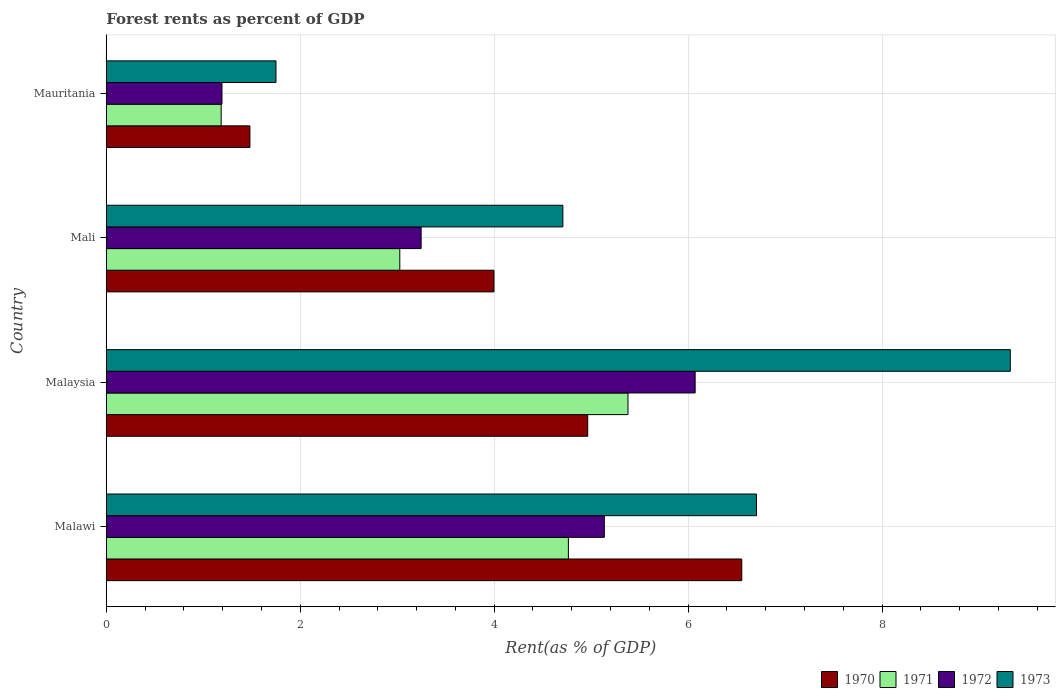How many groups of bars are there?
Your answer should be very brief. 4. Are the number of bars per tick equal to the number of legend labels?
Give a very brief answer. Yes. How many bars are there on the 2nd tick from the top?
Ensure brevity in your answer.  4. How many bars are there on the 3rd tick from the bottom?
Offer a terse response. 4. What is the label of the 4th group of bars from the top?
Provide a short and direct response. Malawi. What is the forest rent in 1972 in Mauritania?
Offer a terse response. 1.19. Across all countries, what is the maximum forest rent in 1971?
Your answer should be compact. 5.38. Across all countries, what is the minimum forest rent in 1972?
Keep it short and to the point. 1.19. In which country was the forest rent in 1972 maximum?
Your response must be concise. Malaysia. In which country was the forest rent in 1973 minimum?
Offer a terse response. Mauritania. What is the total forest rent in 1973 in the graph?
Ensure brevity in your answer.  22.49. What is the difference between the forest rent in 1971 in Malaysia and that in Mali?
Provide a succinct answer. 2.35. What is the difference between the forest rent in 1970 in Malaysia and the forest rent in 1971 in Mauritania?
Keep it short and to the point. 3.78. What is the average forest rent in 1971 per country?
Offer a terse response. 3.59. What is the difference between the forest rent in 1973 and forest rent in 1970 in Mauritania?
Offer a terse response. 0.27. In how many countries, is the forest rent in 1972 greater than 7.2 %?
Give a very brief answer. 0. What is the ratio of the forest rent in 1971 in Malaysia to that in Mali?
Keep it short and to the point. 1.78. Is the forest rent in 1971 in Malaysia less than that in Mali?
Your response must be concise. No. Is the difference between the forest rent in 1973 in Malaysia and Mali greater than the difference between the forest rent in 1970 in Malaysia and Mali?
Provide a short and direct response. Yes. What is the difference between the highest and the second highest forest rent in 1973?
Your answer should be very brief. 2.62. What is the difference between the highest and the lowest forest rent in 1971?
Ensure brevity in your answer.  4.19. In how many countries, is the forest rent in 1972 greater than the average forest rent in 1972 taken over all countries?
Your answer should be compact. 2. Is it the case that in every country, the sum of the forest rent in 1973 and forest rent in 1972 is greater than the sum of forest rent in 1970 and forest rent in 1971?
Your answer should be compact. No. What does the 3rd bar from the top in Mali represents?
Your answer should be very brief. 1971. Is it the case that in every country, the sum of the forest rent in 1972 and forest rent in 1973 is greater than the forest rent in 1971?
Keep it short and to the point. Yes. Are all the bars in the graph horizontal?
Provide a succinct answer. Yes. What is the difference between two consecutive major ticks on the X-axis?
Give a very brief answer. 2. Does the graph contain any zero values?
Provide a short and direct response. No. Does the graph contain grids?
Your response must be concise. Yes. Where does the legend appear in the graph?
Your response must be concise. Bottom right. What is the title of the graph?
Give a very brief answer. Forest rents as percent of GDP. What is the label or title of the X-axis?
Make the answer very short. Rent(as % of GDP). What is the Rent(as % of GDP) of 1970 in Malawi?
Keep it short and to the point. 6.55. What is the Rent(as % of GDP) in 1971 in Malawi?
Offer a terse response. 4.77. What is the Rent(as % of GDP) of 1972 in Malawi?
Provide a succinct answer. 5.14. What is the Rent(as % of GDP) of 1973 in Malawi?
Make the answer very short. 6.71. What is the Rent(as % of GDP) in 1970 in Malaysia?
Offer a very short reply. 4.96. What is the Rent(as % of GDP) in 1971 in Malaysia?
Keep it short and to the point. 5.38. What is the Rent(as % of GDP) of 1972 in Malaysia?
Give a very brief answer. 6.07. What is the Rent(as % of GDP) of 1973 in Malaysia?
Offer a very short reply. 9.32. What is the Rent(as % of GDP) in 1970 in Mali?
Give a very brief answer. 4. What is the Rent(as % of GDP) of 1971 in Mali?
Make the answer very short. 3.03. What is the Rent(as % of GDP) in 1972 in Mali?
Offer a very short reply. 3.25. What is the Rent(as % of GDP) in 1973 in Mali?
Your response must be concise. 4.71. What is the Rent(as % of GDP) of 1970 in Mauritania?
Your answer should be very brief. 1.48. What is the Rent(as % of GDP) in 1971 in Mauritania?
Offer a terse response. 1.19. What is the Rent(as % of GDP) in 1972 in Mauritania?
Your response must be concise. 1.19. What is the Rent(as % of GDP) in 1973 in Mauritania?
Your response must be concise. 1.75. Across all countries, what is the maximum Rent(as % of GDP) of 1970?
Make the answer very short. 6.55. Across all countries, what is the maximum Rent(as % of GDP) of 1971?
Offer a very short reply. 5.38. Across all countries, what is the maximum Rent(as % of GDP) in 1972?
Provide a short and direct response. 6.07. Across all countries, what is the maximum Rent(as % of GDP) of 1973?
Give a very brief answer. 9.32. Across all countries, what is the minimum Rent(as % of GDP) in 1970?
Provide a short and direct response. 1.48. Across all countries, what is the minimum Rent(as % of GDP) of 1971?
Your response must be concise. 1.19. Across all countries, what is the minimum Rent(as % of GDP) in 1972?
Your response must be concise. 1.19. Across all countries, what is the minimum Rent(as % of GDP) in 1973?
Ensure brevity in your answer.  1.75. What is the total Rent(as % of GDP) in 1970 in the graph?
Provide a short and direct response. 17. What is the total Rent(as % of GDP) of 1971 in the graph?
Your response must be concise. 14.36. What is the total Rent(as % of GDP) in 1972 in the graph?
Give a very brief answer. 15.65. What is the total Rent(as % of GDP) of 1973 in the graph?
Give a very brief answer. 22.49. What is the difference between the Rent(as % of GDP) of 1970 in Malawi and that in Malaysia?
Make the answer very short. 1.59. What is the difference between the Rent(as % of GDP) in 1971 in Malawi and that in Malaysia?
Give a very brief answer. -0.61. What is the difference between the Rent(as % of GDP) in 1972 in Malawi and that in Malaysia?
Your answer should be compact. -0.94. What is the difference between the Rent(as % of GDP) in 1973 in Malawi and that in Malaysia?
Keep it short and to the point. -2.62. What is the difference between the Rent(as % of GDP) of 1970 in Malawi and that in Mali?
Your answer should be very brief. 2.55. What is the difference between the Rent(as % of GDP) in 1971 in Malawi and that in Mali?
Make the answer very short. 1.74. What is the difference between the Rent(as % of GDP) of 1972 in Malawi and that in Mali?
Your answer should be very brief. 1.89. What is the difference between the Rent(as % of GDP) in 1973 in Malawi and that in Mali?
Give a very brief answer. 2. What is the difference between the Rent(as % of GDP) of 1970 in Malawi and that in Mauritania?
Make the answer very short. 5.07. What is the difference between the Rent(as % of GDP) in 1971 in Malawi and that in Mauritania?
Your answer should be compact. 3.58. What is the difference between the Rent(as % of GDP) in 1972 in Malawi and that in Mauritania?
Offer a terse response. 3.94. What is the difference between the Rent(as % of GDP) of 1973 in Malawi and that in Mauritania?
Provide a short and direct response. 4.96. What is the difference between the Rent(as % of GDP) of 1970 in Malaysia and that in Mali?
Offer a very short reply. 0.97. What is the difference between the Rent(as % of GDP) in 1971 in Malaysia and that in Mali?
Give a very brief answer. 2.35. What is the difference between the Rent(as % of GDP) of 1972 in Malaysia and that in Mali?
Ensure brevity in your answer.  2.83. What is the difference between the Rent(as % of GDP) of 1973 in Malaysia and that in Mali?
Your response must be concise. 4.61. What is the difference between the Rent(as % of GDP) of 1970 in Malaysia and that in Mauritania?
Your answer should be compact. 3.48. What is the difference between the Rent(as % of GDP) of 1971 in Malaysia and that in Mauritania?
Give a very brief answer. 4.19. What is the difference between the Rent(as % of GDP) of 1972 in Malaysia and that in Mauritania?
Your answer should be compact. 4.88. What is the difference between the Rent(as % of GDP) of 1973 in Malaysia and that in Mauritania?
Your response must be concise. 7.57. What is the difference between the Rent(as % of GDP) in 1970 in Mali and that in Mauritania?
Give a very brief answer. 2.52. What is the difference between the Rent(as % of GDP) in 1971 in Mali and that in Mauritania?
Offer a terse response. 1.84. What is the difference between the Rent(as % of GDP) in 1972 in Mali and that in Mauritania?
Your response must be concise. 2.05. What is the difference between the Rent(as % of GDP) of 1973 in Mali and that in Mauritania?
Your answer should be compact. 2.96. What is the difference between the Rent(as % of GDP) of 1970 in Malawi and the Rent(as % of GDP) of 1971 in Malaysia?
Offer a very short reply. 1.17. What is the difference between the Rent(as % of GDP) of 1970 in Malawi and the Rent(as % of GDP) of 1972 in Malaysia?
Provide a short and direct response. 0.48. What is the difference between the Rent(as % of GDP) of 1970 in Malawi and the Rent(as % of GDP) of 1973 in Malaysia?
Your answer should be compact. -2.77. What is the difference between the Rent(as % of GDP) in 1971 in Malawi and the Rent(as % of GDP) in 1972 in Malaysia?
Your answer should be very brief. -1.31. What is the difference between the Rent(as % of GDP) of 1971 in Malawi and the Rent(as % of GDP) of 1973 in Malaysia?
Your response must be concise. -4.56. What is the difference between the Rent(as % of GDP) in 1972 in Malawi and the Rent(as % of GDP) in 1973 in Malaysia?
Ensure brevity in your answer.  -4.19. What is the difference between the Rent(as % of GDP) of 1970 in Malawi and the Rent(as % of GDP) of 1971 in Mali?
Your response must be concise. 3.53. What is the difference between the Rent(as % of GDP) of 1970 in Malawi and the Rent(as % of GDP) of 1972 in Mali?
Your answer should be very brief. 3.31. What is the difference between the Rent(as % of GDP) in 1970 in Malawi and the Rent(as % of GDP) in 1973 in Mali?
Offer a very short reply. 1.84. What is the difference between the Rent(as % of GDP) of 1971 in Malawi and the Rent(as % of GDP) of 1972 in Mali?
Give a very brief answer. 1.52. What is the difference between the Rent(as % of GDP) in 1971 in Malawi and the Rent(as % of GDP) in 1973 in Mali?
Give a very brief answer. 0.06. What is the difference between the Rent(as % of GDP) in 1972 in Malawi and the Rent(as % of GDP) in 1973 in Mali?
Give a very brief answer. 0.43. What is the difference between the Rent(as % of GDP) in 1970 in Malawi and the Rent(as % of GDP) in 1971 in Mauritania?
Ensure brevity in your answer.  5.37. What is the difference between the Rent(as % of GDP) in 1970 in Malawi and the Rent(as % of GDP) in 1972 in Mauritania?
Ensure brevity in your answer.  5.36. What is the difference between the Rent(as % of GDP) in 1970 in Malawi and the Rent(as % of GDP) in 1973 in Mauritania?
Offer a terse response. 4.8. What is the difference between the Rent(as % of GDP) in 1971 in Malawi and the Rent(as % of GDP) in 1972 in Mauritania?
Keep it short and to the point. 3.57. What is the difference between the Rent(as % of GDP) of 1971 in Malawi and the Rent(as % of GDP) of 1973 in Mauritania?
Your answer should be compact. 3.02. What is the difference between the Rent(as % of GDP) in 1972 in Malawi and the Rent(as % of GDP) in 1973 in Mauritania?
Keep it short and to the point. 3.39. What is the difference between the Rent(as % of GDP) in 1970 in Malaysia and the Rent(as % of GDP) in 1971 in Mali?
Your answer should be compact. 1.94. What is the difference between the Rent(as % of GDP) in 1970 in Malaysia and the Rent(as % of GDP) in 1972 in Mali?
Provide a short and direct response. 1.72. What is the difference between the Rent(as % of GDP) in 1970 in Malaysia and the Rent(as % of GDP) in 1973 in Mali?
Provide a succinct answer. 0.26. What is the difference between the Rent(as % of GDP) of 1971 in Malaysia and the Rent(as % of GDP) of 1972 in Mali?
Provide a succinct answer. 2.13. What is the difference between the Rent(as % of GDP) of 1971 in Malaysia and the Rent(as % of GDP) of 1973 in Mali?
Make the answer very short. 0.67. What is the difference between the Rent(as % of GDP) of 1972 in Malaysia and the Rent(as % of GDP) of 1973 in Mali?
Make the answer very short. 1.36. What is the difference between the Rent(as % of GDP) of 1970 in Malaysia and the Rent(as % of GDP) of 1971 in Mauritania?
Offer a very short reply. 3.78. What is the difference between the Rent(as % of GDP) in 1970 in Malaysia and the Rent(as % of GDP) in 1972 in Mauritania?
Offer a terse response. 3.77. What is the difference between the Rent(as % of GDP) of 1970 in Malaysia and the Rent(as % of GDP) of 1973 in Mauritania?
Keep it short and to the point. 3.21. What is the difference between the Rent(as % of GDP) of 1971 in Malaysia and the Rent(as % of GDP) of 1972 in Mauritania?
Give a very brief answer. 4.19. What is the difference between the Rent(as % of GDP) in 1971 in Malaysia and the Rent(as % of GDP) in 1973 in Mauritania?
Keep it short and to the point. 3.63. What is the difference between the Rent(as % of GDP) of 1972 in Malaysia and the Rent(as % of GDP) of 1973 in Mauritania?
Make the answer very short. 4.32. What is the difference between the Rent(as % of GDP) of 1970 in Mali and the Rent(as % of GDP) of 1971 in Mauritania?
Make the answer very short. 2.81. What is the difference between the Rent(as % of GDP) in 1970 in Mali and the Rent(as % of GDP) in 1972 in Mauritania?
Provide a succinct answer. 2.8. What is the difference between the Rent(as % of GDP) in 1970 in Mali and the Rent(as % of GDP) in 1973 in Mauritania?
Give a very brief answer. 2.25. What is the difference between the Rent(as % of GDP) in 1971 in Mali and the Rent(as % of GDP) in 1972 in Mauritania?
Provide a short and direct response. 1.83. What is the difference between the Rent(as % of GDP) of 1971 in Mali and the Rent(as % of GDP) of 1973 in Mauritania?
Make the answer very short. 1.28. What is the difference between the Rent(as % of GDP) of 1972 in Mali and the Rent(as % of GDP) of 1973 in Mauritania?
Give a very brief answer. 1.5. What is the average Rent(as % of GDP) of 1970 per country?
Give a very brief answer. 4.25. What is the average Rent(as % of GDP) in 1971 per country?
Give a very brief answer. 3.59. What is the average Rent(as % of GDP) in 1972 per country?
Provide a short and direct response. 3.91. What is the average Rent(as % of GDP) in 1973 per country?
Provide a succinct answer. 5.62. What is the difference between the Rent(as % of GDP) in 1970 and Rent(as % of GDP) in 1971 in Malawi?
Offer a very short reply. 1.79. What is the difference between the Rent(as % of GDP) in 1970 and Rent(as % of GDP) in 1972 in Malawi?
Your response must be concise. 1.42. What is the difference between the Rent(as % of GDP) of 1970 and Rent(as % of GDP) of 1973 in Malawi?
Your answer should be very brief. -0.15. What is the difference between the Rent(as % of GDP) in 1971 and Rent(as % of GDP) in 1972 in Malawi?
Provide a short and direct response. -0.37. What is the difference between the Rent(as % of GDP) of 1971 and Rent(as % of GDP) of 1973 in Malawi?
Your answer should be very brief. -1.94. What is the difference between the Rent(as % of GDP) in 1972 and Rent(as % of GDP) in 1973 in Malawi?
Provide a short and direct response. -1.57. What is the difference between the Rent(as % of GDP) of 1970 and Rent(as % of GDP) of 1971 in Malaysia?
Ensure brevity in your answer.  -0.42. What is the difference between the Rent(as % of GDP) in 1970 and Rent(as % of GDP) in 1972 in Malaysia?
Ensure brevity in your answer.  -1.11. What is the difference between the Rent(as % of GDP) of 1970 and Rent(as % of GDP) of 1973 in Malaysia?
Your answer should be very brief. -4.36. What is the difference between the Rent(as % of GDP) of 1971 and Rent(as % of GDP) of 1972 in Malaysia?
Keep it short and to the point. -0.69. What is the difference between the Rent(as % of GDP) of 1971 and Rent(as % of GDP) of 1973 in Malaysia?
Your answer should be compact. -3.94. What is the difference between the Rent(as % of GDP) of 1972 and Rent(as % of GDP) of 1973 in Malaysia?
Make the answer very short. -3.25. What is the difference between the Rent(as % of GDP) in 1970 and Rent(as % of GDP) in 1971 in Mali?
Give a very brief answer. 0.97. What is the difference between the Rent(as % of GDP) in 1970 and Rent(as % of GDP) in 1972 in Mali?
Ensure brevity in your answer.  0.75. What is the difference between the Rent(as % of GDP) of 1970 and Rent(as % of GDP) of 1973 in Mali?
Your response must be concise. -0.71. What is the difference between the Rent(as % of GDP) in 1971 and Rent(as % of GDP) in 1972 in Mali?
Provide a succinct answer. -0.22. What is the difference between the Rent(as % of GDP) in 1971 and Rent(as % of GDP) in 1973 in Mali?
Give a very brief answer. -1.68. What is the difference between the Rent(as % of GDP) in 1972 and Rent(as % of GDP) in 1973 in Mali?
Keep it short and to the point. -1.46. What is the difference between the Rent(as % of GDP) of 1970 and Rent(as % of GDP) of 1971 in Mauritania?
Offer a terse response. 0.3. What is the difference between the Rent(as % of GDP) in 1970 and Rent(as % of GDP) in 1972 in Mauritania?
Offer a very short reply. 0.29. What is the difference between the Rent(as % of GDP) of 1970 and Rent(as % of GDP) of 1973 in Mauritania?
Your response must be concise. -0.27. What is the difference between the Rent(as % of GDP) of 1971 and Rent(as % of GDP) of 1972 in Mauritania?
Provide a short and direct response. -0.01. What is the difference between the Rent(as % of GDP) of 1971 and Rent(as % of GDP) of 1973 in Mauritania?
Offer a terse response. -0.57. What is the difference between the Rent(as % of GDP) in 1972 and Rent(as % of GDP) in 1973 in Mauritania?
Ensure brevity in your answer.  -0.56. What is the ratio of the Rent(as % of GDP) in 1970 in Malawi to that in Malaysia?
Offer a very short reply. 1.32. What is the ratio of the Rent(as % of GDP) of 1971 in Malawi to that in Malaysia?
Your answer should be very brief. 0.89. What is the ratio of the Rent(as % of GDP) in 1972 in Malawi to that in Malaysia?
Keep it short and to the point. 0.85. What is the ratio of the Rent(as % of GDP) in 1973 in Malawi to that in Malaysia?
Your answer should be very brief. 0.72. What is the ratio of the Rent(as % of GDP) of 1970 in Malawi to that in Mali?
Your answer should be very brief. 1.64. What is the ratio of the Rent(as % of GDP) in 1971 in Malawi to that in Mali?
Offer a very short reply. 1.57. What is the ratio of the Rent(as % of GDP) in 1972 in Malawi to that in Mali?
Provide a short and direct response. 1.58. What is the ratio of the Rent(as % of GDP) of 1973 in Malawi to that in Mali?
Keep it short and to the point. 1.42. What is the ratio of the Rent(as % of GDP) of 1970 in Malawi to that in Mauritania?
Offer a very short reply. 4.42. What is the ratio of the Rent(as % of GDP) of 1971 in Malawi to that in Mauritania?
Your response must be concise. 4.02. What is the ratio of the Rent(as % of GDP) in 1972 in Malawi to that in Mauritania?
Keep it short and to the point. 4.3. What is the ratio of the Rent(as % of GDP) of 1973 in Malawi to that in Mauritania?
Your response must be concise. 3.83. What is the ratio of the Rent(as % of GDP) in 1970 in Malaysia to that in Mali?
Your response must be concise. 1.24. What is the ratio of the Rent(as % of GDP) of 1971 in Malaysia to that in Mali?
Your response must be concise. 1.78. What is the ratio of the Rent(as % of GDP) in 1972 in Malaysia to that in Mali?
Offer a very short reply. 1.87. What is the ratio of the Rent(as % of GDP) in 1973 in Malaysia to that in Mali?
Keep it short and to the point. 1.98. What is the ratio of the Rent(as % of GDP) of 1970 in Malaysia to that in Mauritania?
Offer a very short reply. 3.35. What is the ratio of the Rent(as % of GDP) in 1971 in Malaysia to that in Mauritania?
Offer a terse response. 4.54. What is the ratio of the Rent(as % of GDP) of 1972 in Malaysia to that in Mauritania?
Provide a short and direct response. 5.09. What is the ratio of the Rent(as % of GDP) in 1973 in Malaysia to that in Mauritania?
Give a very brief answer. 5.33. What is the ratio of the Rent(as % of GDP) in 1970 in Mali to that in Mauritania?
Keep it short and to the point. 2.7. What is the ratio of the Rent(as % of GDP) in 1971 in Mali to that in Mauritania?
Your response must be concise. 2.55. What is the ratio of the Rent(as % of GDP) in 1972 in Mali to that in Mauritania?
Provide a short and direct response. 2.72. What is the ratio of the Rent(as % of GDP) in 1973 in Mali to that in Mauritania?
Offer a very short reply. 2.69. What is the difference between the highest and the second highest Rent(as % of GDP) of 1970?
Offer a very short reply. 1.59. What is the difference between the highest and the second highest Rent(as % of GDP) in 1971?
Your response must be concise. 0.61. What is the difference between the highest and the second highest Rent(as % of GDP) of 1972?
Provide a short and direct response. 0.94. What is the difference between the highest and the second highest Rent(as % of GDP) in 1973?
Your answer should be very brief. 2.62. What is the difference between the highest and the lowest Rent(as % of GDP) in 1970?
Ensure brevity in your answer.  5.07. What is the difference between the highest and the lowest Rent(as % of GDP) in 1971?
Your answer should be very brief. 4.19. What is the difference between the highest and the lowest Rent(as % of GDP) of 1972?
Your answer should be compact. 4.88. What is the difference between the highest and the lowest Rent(as % of GDP) in 1973?
Provide a succinct answer. 7.57. 